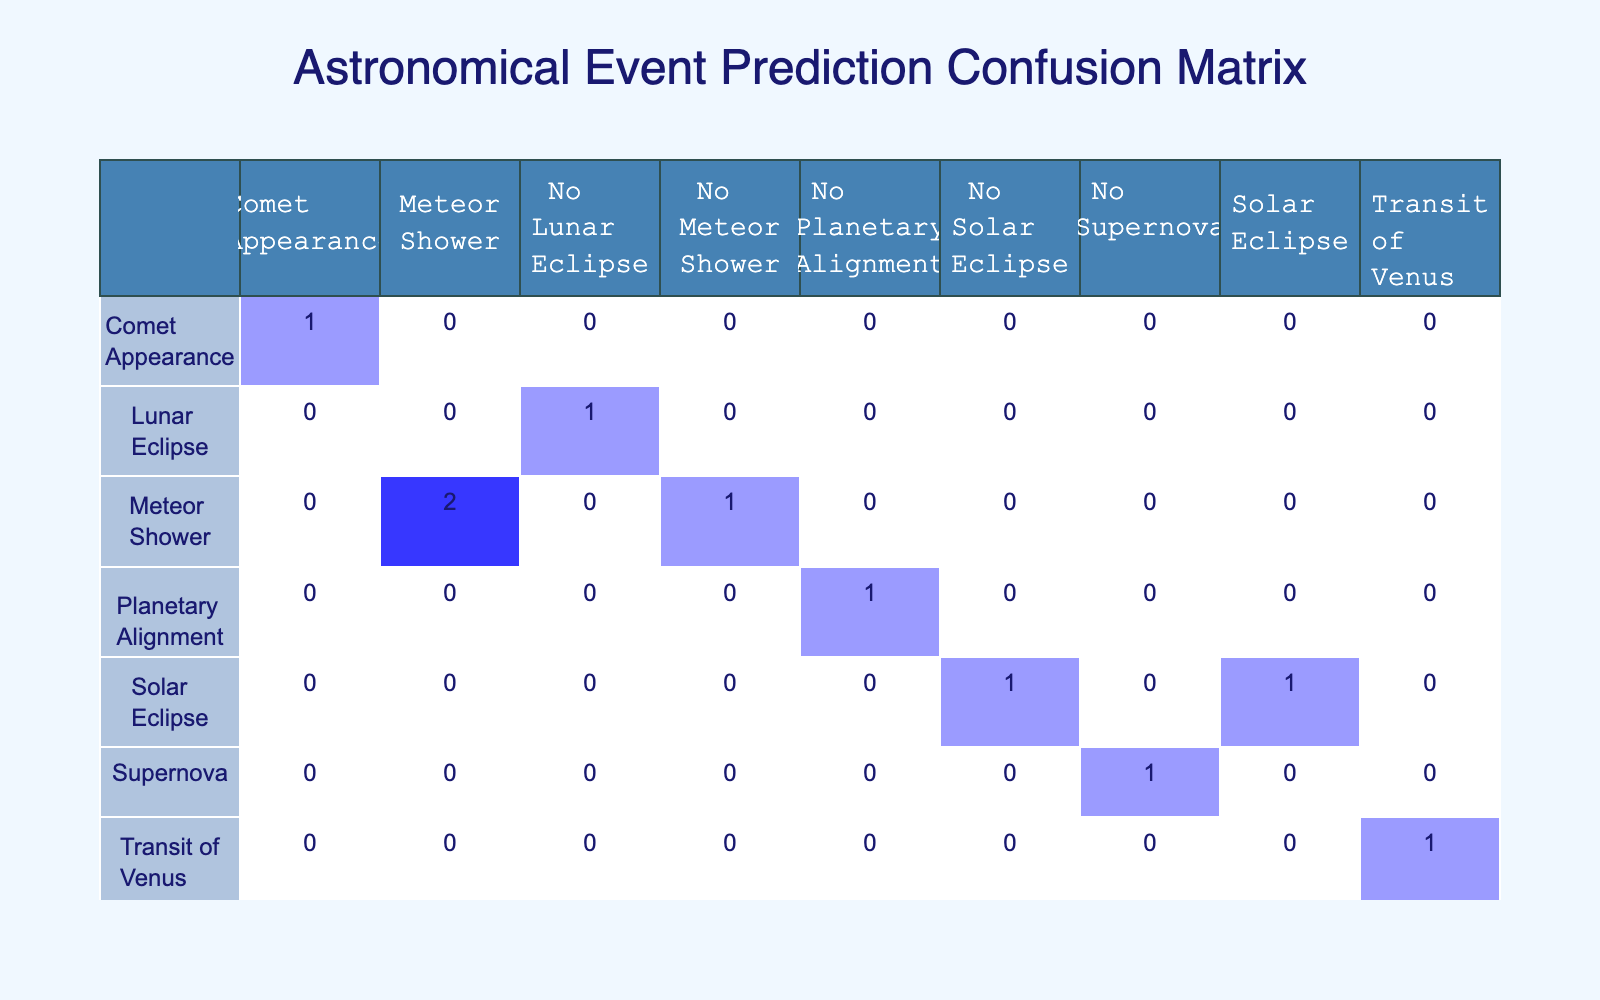What is the number of true positive predictions for Meteor Showers? True positive predictions occur when the predicted events match the actual events. In the table, the predictions for Meteor Shower that match with actual Meteor Shower events are two: Perseids and Quadrantids.
Answer: 2 How many events were incorrectly predicted as Lunar Eclipses? The events that were incorrectly predicted as Lunar Eclipses were the ones that are not actual Lunar Eclipses. According to the table, there was one instance (Partial Lunar Eclipse) where the prediction was "Lunar Eclipse" but the actual event was "No Lunar Eclipse".
Answer: 1 Is there a prediction for more than one type of Solar Eclipse? To determine this, we should look for counts of predicted Solar Eclipses. The table shows one correct prediction (Total Solar Eclipse) and one incorrect prediction (Annular Solar Eclipse). Since only one unique type is listed (even though it has different actual events), the answer is yes, there are predictions for different types, but the types themselves aren’t counted separately in this data.
Answer: Yes What is the total count of events that were correctly predicted? To find the total count of correctly predicted events, we sum the occurrences where the predicted and actual columns match. According to the table, such instances are: Perseids, Total Solar Eclipse, Comet Appearance, Transit of Venus, and Quadrantids, totaling five correctly predicted events.
Answer: 5 Which event had the highest number of prediction errors? Evaluating the errors involves comparing the predicted events against their actual counterparts and counting the discrepancies. "Meteor Shower" occurs twice with one true positive and one false negative (Geminids), and "Solar Eclipse" occurs twice with one true positive and one false positive (Annular Solar Eclipse). Therefore, it appears that the 'Meteor Shower' predictions yield two prediction errors: it's both falsely predicted and actually one of the events.
Answer: Meteor Shower 